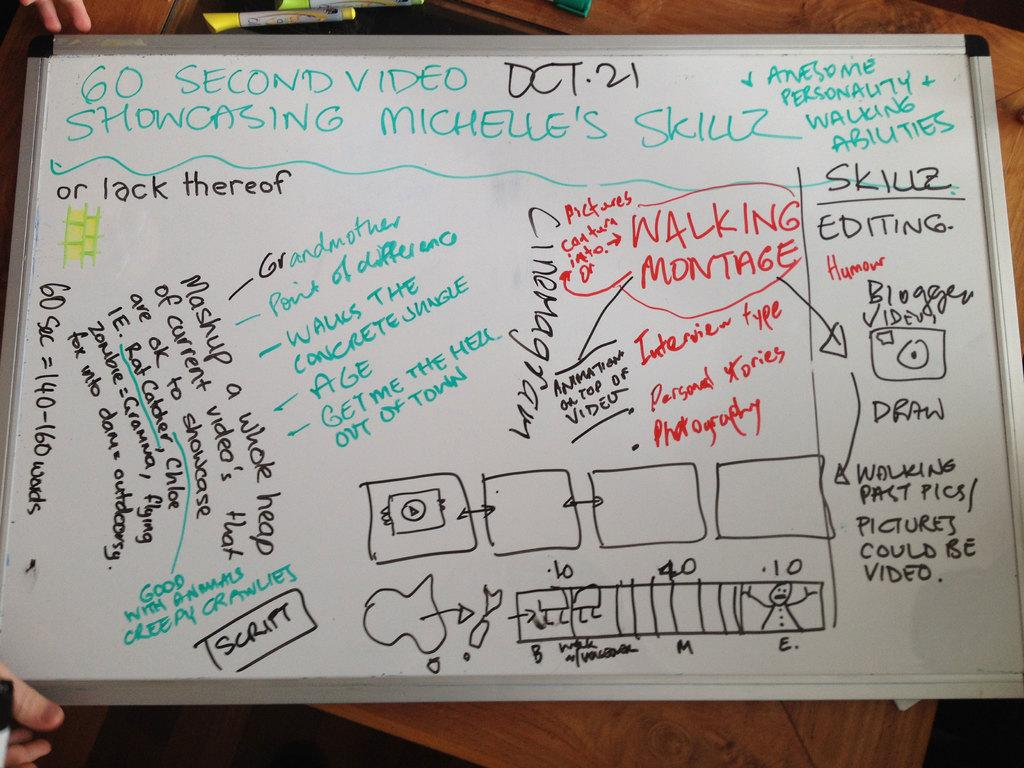<image>
Offer a succinct explanation of the picture presented. A whiteboard outlining the different elements contained within Michelle's video resume. 